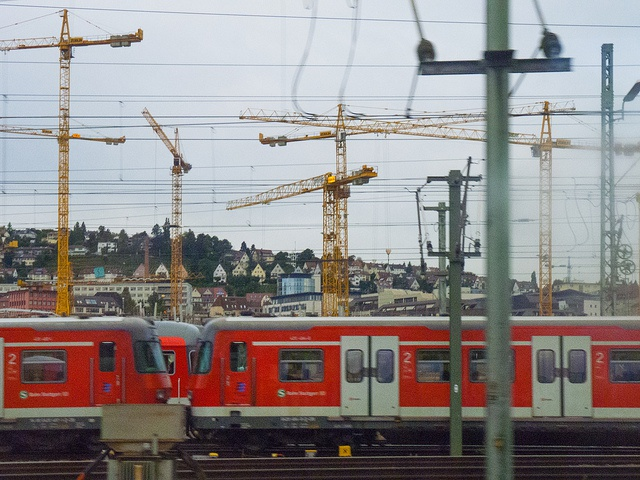Describe the objects in this image and their specific colors. I can see train in darkgray, brown, gray, and black tones and train in darkgray, maroon, gray, and black tones in this image. 